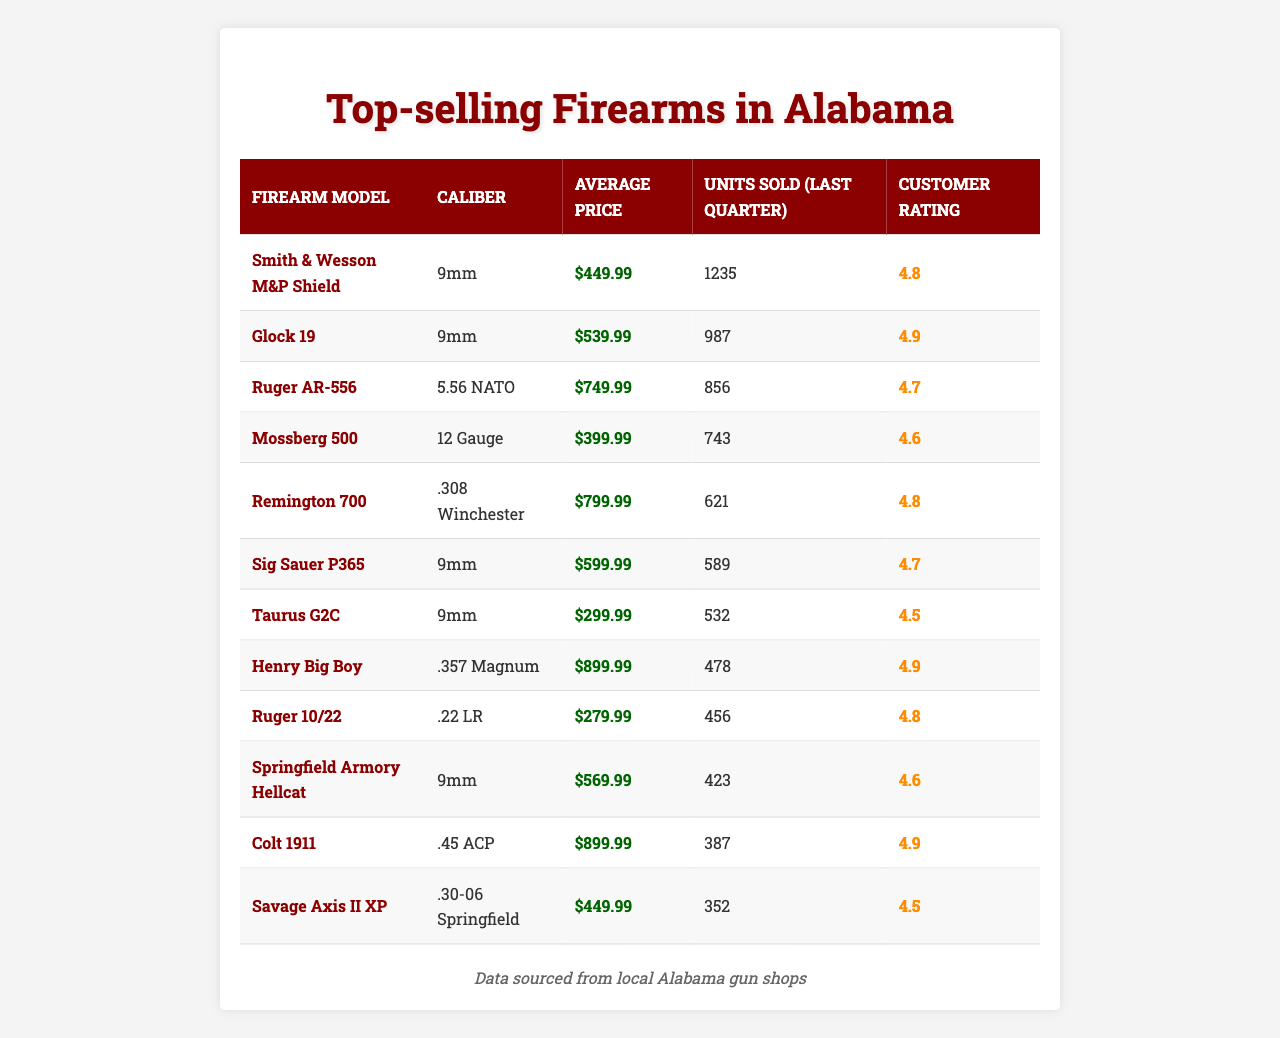What is the best-selling firearm model in Alabama based on units sold? The best-selling model is Smith & Wesson M&P Shield, with 1,235 units sold in the last quarter, which is the highest number in the table.
Answer: Smith & Wesson M&P Shield What caliber is most frequently associated with the top-selling firearms? The 9mm caliber appears most frequently among the top-selling firearms, as it is listed for 4 different models in the table.
Answer: 9mm Which firearm model has the highest average price? The firearm with the highest average price is the Colt 1911, priced at $899.99, which can be directly retrieved from the "Average Price" column in the table.
Answer: Colt 1911 What's the average customer rating for firearms chambered in 9mm? To find the average rating, sum ratings of the 9mm models: (4.8 + 4.9 + 4.7 + 4.5 + 4.6) = 24.5. There are 5 models, so the average is 24.5/5 = 4.9.
Answer: 4.9 Is there a firearm model that is rated below 4.5? Yes, the Taurus G2C is rated 4.5, and the Savage Axis II XP is also rated 4.5, which confirms that there are models rated lower than 4.5 in the given data.
Answer: Yes Which firearm caliber has sold the most units in total? To find the total units sold per caliber, calculate: 9mm (1235 + 987 + 589 + 532 + 423 = 3766), 5.56 NATO (856), 12 Gauge (743), and so on. The highest sum is for 9mm at 3766, making it the top caliber.
Answer: 9mm How many units were sold for firearm models priced above $700? The models priced over $700 are: Ruger AR-556 (856), Remington 700 (621), Henry Big Boy (478), and Colt 1911 (387). Summing these gives 856 + 621 + 478 + 387 = 2342.
Answer: 2342 Which two models have the same caliber and how many units were sold for each? The Glock 19 and Sig Sauer P365 both are chambered in 9mm, selling 987 and 589 units respectively.
Answer: Glock 19: 987, Sig Sauer P365: 589 What is the customer rating difference between the highest and lowest rated firearms in the table? The highest rating is 4.9 (Glock 19 and Colt 1911), and the lowest is 4.5 (Taurus G2C and Savage Axis II XP). The difference is 4.9 - 4.5 = 0.4.
Answer: 0.4 What percentage of the total units sold in the last quarter does the Smith & Wesson M&P Shield represent? Total units sold in the last quarter is 1235 + 987 + 856 + 743 + 621 + 589 + 532 + 478 + 456 + 423 + 387 + 352 = 7353. Smith & Wesson M&P Shield sold 1235, so percentage is (1235 / 7353) * 100 = about 16.8%.
Answer: 16.8% 